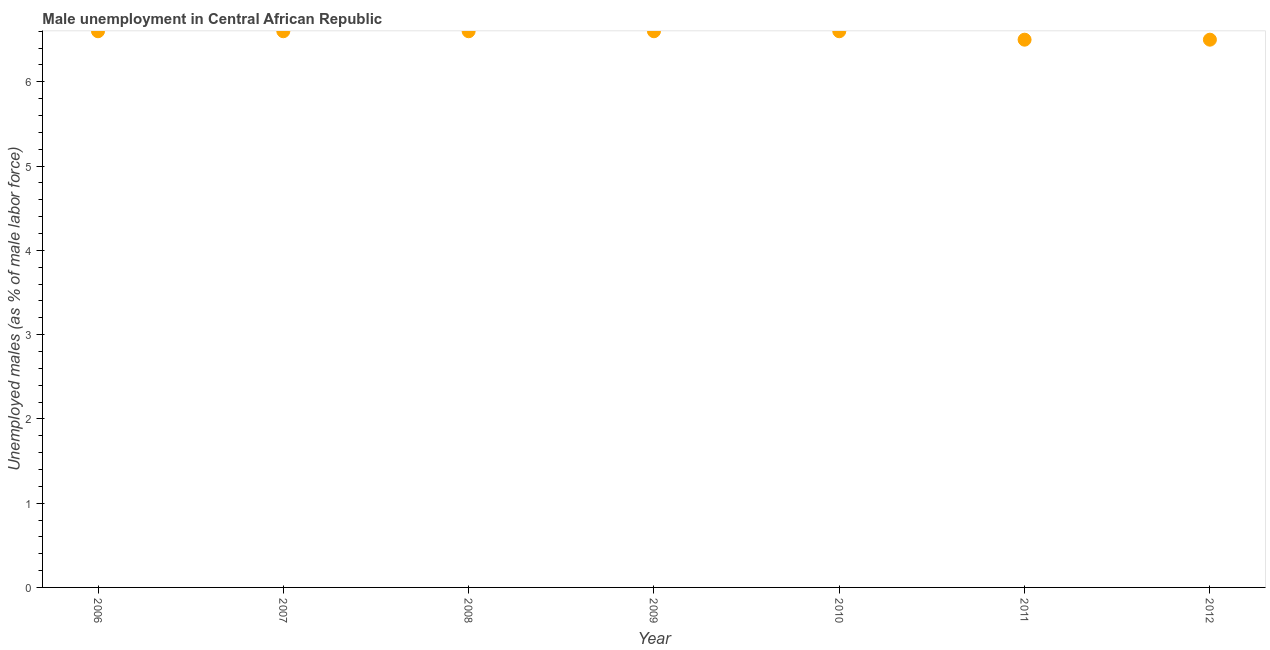What is the unemployed males population in 2006?
Your answer should be very brief. 6.6. Across all years, what is the maximum unemployed males population?
Your answer should be compact. 6.6. In which year was the unemployed males population maximum?
Keep it short and to the point. 2006. What is the sum of the unemployed males population?
Offer a very short reply. 46. What is the difference between the unemployed males population in 2009 and 2012?
Your answer should be compact. 0.1. What is the average unemployed males population per year?
Provide a short and direct response. 6.57. What is the median unemployed males population?
Provide a succinct answer. 6.6. What is the ratio of the unemployed males population in 2008 to that in 2012?
Your answer should be compact. 1.02. What is the difference between the highest and the lowest unemployed males population?
Provide a succinct answer. 0.1. In how many years, is the unemployed males population greater than the average unemployed males population taken over all years?
Your answer should be very brief. 5. Does the unemployed males population monotonically increase over the years?
Make the answer very short. No. How many dotlines are there?
Offer a very short reply. 1. How many years are there in the graph?
Your answer should be very brief. 7. Are the values on the major ticks of Y-axis written in scientific E-notation?
Keep it short and to the point. No. What is the title of the graph?
Make the answer very short. Male unemployment in Central African Republic. What is the label or title of the Y-axis?
Provide a succinct answer. Unemployed males (as % of male labor force). What is the Unemployed males (as % of male labor force) in 2006?
Your response must be concise. 6.6. What is the Unemployed males (as % of male labor force) in 2007?
Make the answer very short. 6.6. What is the Unemployed males (as % of male labor force) in 2008?
Your response must be concise. 6.6. What is the Unemployed males (as % of male labor force) in 2009?
Your answer should be compact. 6.6. What is the Unemployed males (as % of male labor force) in 2010?
Your answer should be very brief. 6.6. What is the Unemployed males (as % of male labor force) in 2011?
Keep it short and to the point. 6.5. What is the difference between the Unemployed males (as % of male labor force) in 2006 and 2007?
Your answer should be very brief. 0. What is the difference between the Unemployed males (as % of male labor force) in 2006 and 2009?
Provide a short and direct response. 0. What is the difference between the Unemployed males (as % of male labor force) in 2006 and 2010?
Make the answer very short. 0. What is the difference between the Unemployed males (as % of male labor force) in 2006 and 2012?
Offer a terse response. 0.1. What is the difference between the Unemployed males (as % of male labor force) in 2008 and 2009?
Provide a short and direct response. 0. What is the difference between the Unemployed males (as % of male labor force) in 2008 and 2012?
Your response must be concise. 0.1. What is the difference between the Unemployed males (as % of male labor force) in 2009 and 2010?
Your answer should be very brief. 0. What is the difference between the Unemployed males (as % of male labor force) in 2011 and 2012?
Keep it short and to the point. 0. What is the ratio of the Unemployed males (as % of male labor force) in 2006 to that in 2008?
Your answer should be very brief. 1. What is the ratio of the Unemployed males (as % of male labor force) in 2006 to that in 2010?
Keep it short and to the point. 1. What is the ratio of the Unemployed males (as % of male labor force) in 2006 to that in 2011?
Offer a very short reply. 1.01. What is the ratio of the Unemployed males (as % of male labor force) in 2006 to that in 2012?
Offer a terse response. 1.01. What is the ratio of the Unemployed males (as % of male labor force) in 2007 to that in 2009?
Your answer should be compact. 1. What is the ratio of the Unemployed males (as % of male labor force) in 2008 to that in 2011?
Ensure brevity in your answer.  1.01. What is the ratio of the Unemployed males (as % of male labor force) in 2010 to that in 2011?
Ensure brevity in your answer.  1.01. What is the ratio of the Unemployed males (as % of male labor force) in 2011 to that in 2012?
Offer a terse response. 1. 